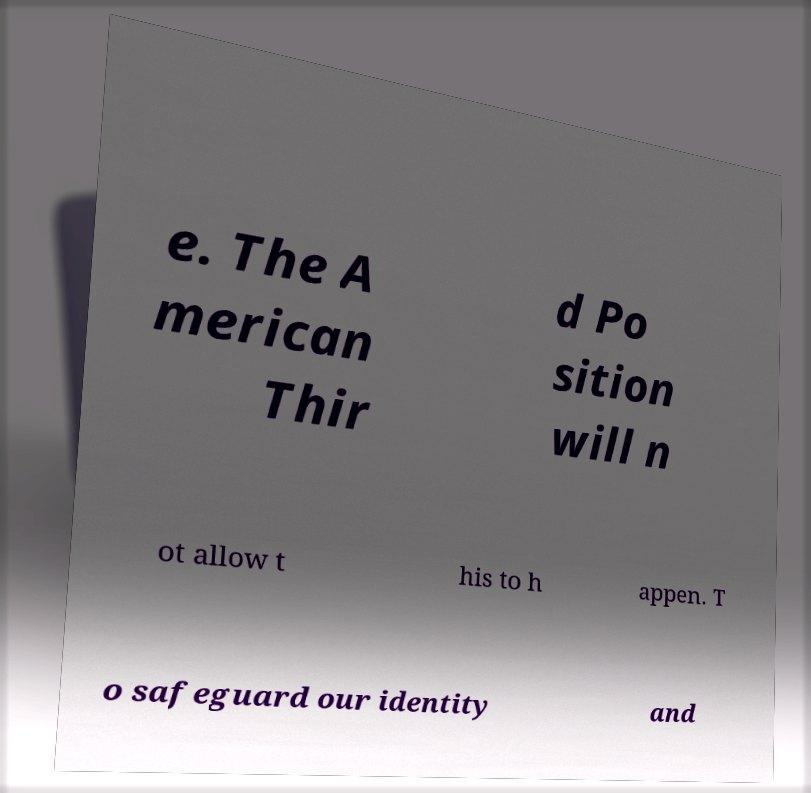Could you assist in decoding the text presented in this image and type it out clearly? e. The A merican Thir d Po sition will n ot allow t his to h appen. T o safeguard our identity and 